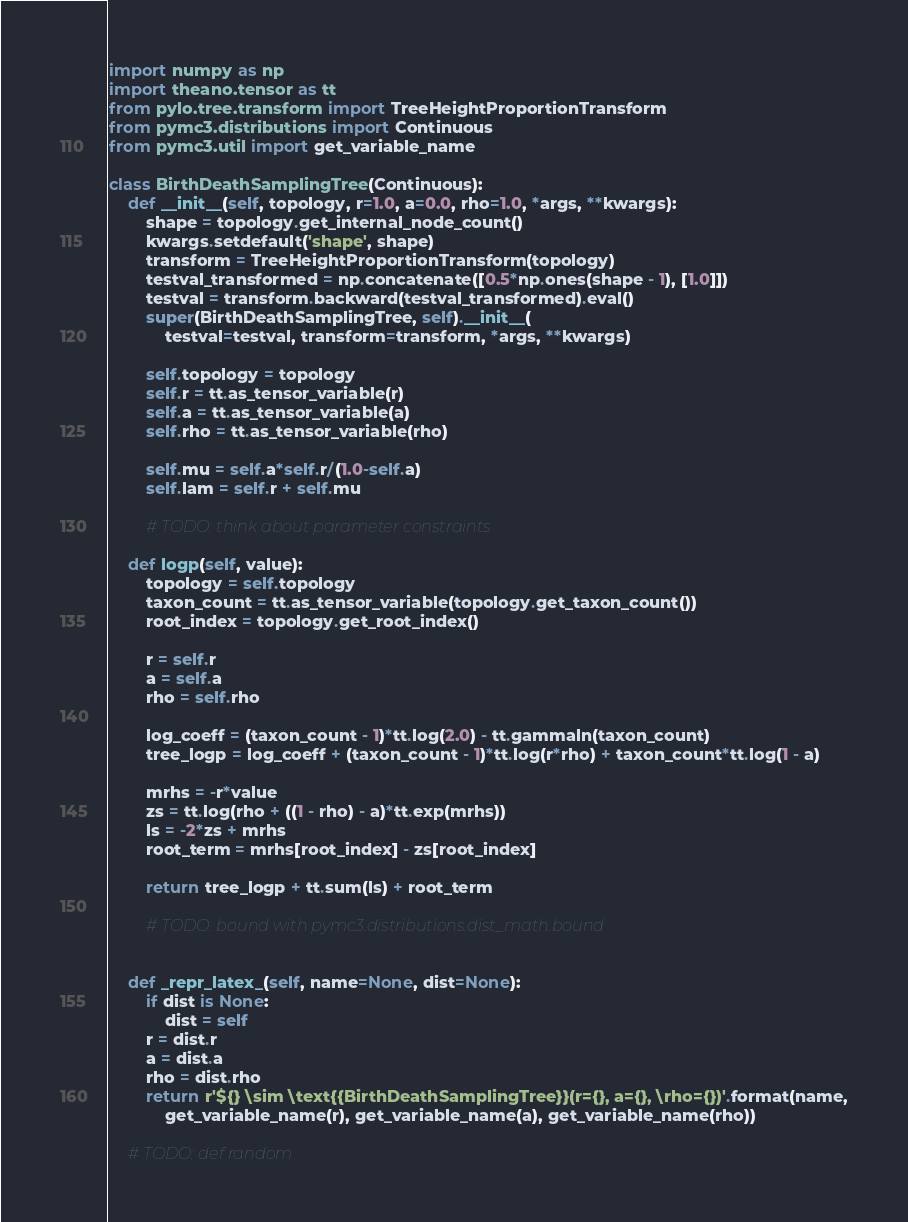<code> <loc_0><loc_0><loc_500><loc_500><_Python_>import numpy as np
import theano.tensor as tt
from pylo.tree.transform import TreeHeightProportionTransform
from pymc3.distributions import Continuous
from pymc3.util import get_variable_name

class BirthDeathSamplingTree(Continuous):
    def __init__(self, topology, r=1.0, a=0.0, rho=1.0, *args, **kwargs):
        shape = topology.get_internal_node_count()
        kwargs.setdefault('shape', shape)
        transform = TreeHeightProportionTransform(topology)
        testval_transformed = np.concatenate([0.5*np.ones(shape - 1), [1.0]])
        testval = transform.backward(testval_transformed).eval() 
        super(BirthDeathSamplingTree, self).__init__(
            testval=testval, transform=transform, *args, **kwargs)

        self.topology = topology
        self.r = tt.as_tensor_variable(r)
        self.a = tt.as_tensor_variable(a)
        self.rho = tt.as_tensor_variable(rho)

        self.mu = self.a*self.r/(1.0-self.a)
        self.lam = self.r + self.mu

        # TODO: think about parameter constraints

    def logp(self, value):
        topology = self.topology
        taxon_count = tt.as_tensor_variable(topology.get_taxon_count())
        root_index = topology.get_root_index()
       
        r = self.r
        a = self.a
        rho = self.rho

        log_coeff = (taxon_count - 1)*tt.log(2.0) - tt.gammaln(taxon_count)
        tree_logp = log_coeff + (taxon_count - 1)*tt.log(r*rho) + taxon_count*tt.log(1 - a)
        
        mrhs = -r*value
        zs = tt.log(rho + ((1 - rho) - a)*tt.exp(mrhs))
        ls = -2*zs + mrhs
        root_term = mrhs[root_index] - zs[root_index]
        
        return tree_logp + tt.sum(ls) + root_term
        
        # TODO: bound with pymc3.distributions.dist_math.bound


    def _repr_latex_(self, name=None, dist=None):
        if dist is None:
            dist = self
        r = dist.r
        a = dist.a
        rho = dist.rho
        return r'${} \sim \text{{BirthDeathSamplingTree}}(r={}, a={}, \rho={})'.format(name,
            get_variable_name(r), get_variable_name(a), get_variable_name(rho))

    # TODO: def random
</code> 